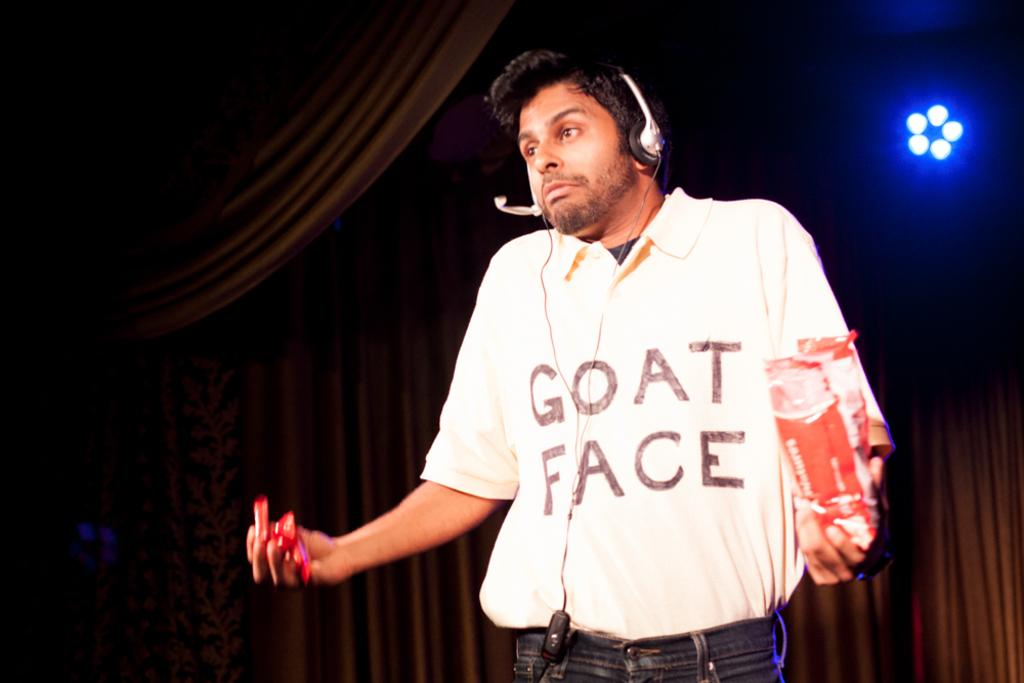What is the main subject of the picture? The main subject of the picture is a man. What is the man doing in the picture? The man is standing in the picture. What is the man wearing on his head? The man is wearing a headset in the picture. What is the man holding in each hand? The man is holding a cover in one hand and candies in the other hand. What else can be seen in the picture besides the man? There are clothes and lights visible in the picture. What type of ray is swimming in the picture? There is no ray present in the picture; it features a man standing with a headset, holding a cover and candies, and surrounded by clothes and lights. 